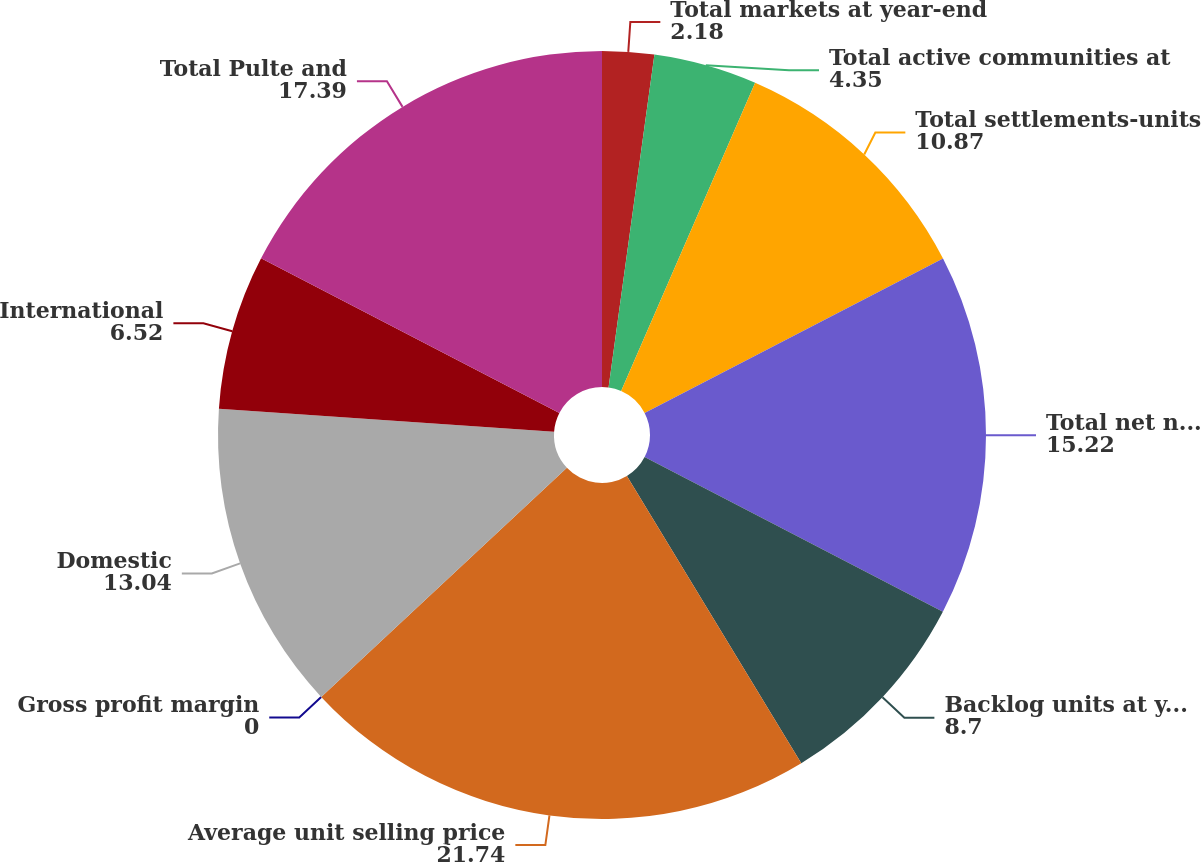<chart> <loc_0><loc_0><loc_500><loc_500><pie_chart><fcel>Total markets at year-end<fcel>Total active communities at<fcel>Total settlements-units<fcel>Total net new orders-units<fcel>Backlog units at year-end<fcel>Average unit selling price<fcel>Gross profit margin<fcel>Domestic<fcel>International<fcel>Total Pulte and<nl><fcel>2.18%<fcel>4.35%<fcel>10.87%<fcel>15.22%<fcel>8.7%<fcel>21.74%<fcel>0.0%<fcel>13.04%<fcel>6.52%<fcel>17.39%<nl></chart> 